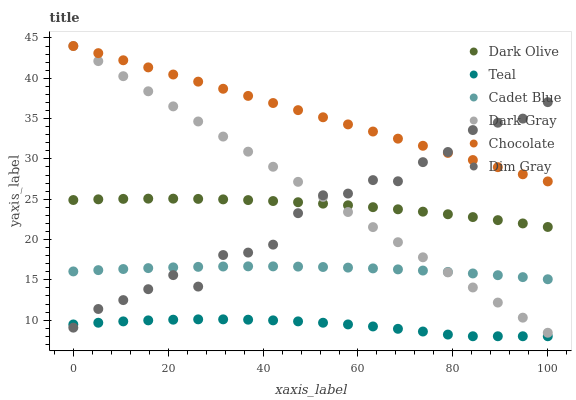Does Teal have the minimum area under the curve?
Answer yes or no. Yes. Does Chocolate have the maximum area under the curve?
Answer yes or no. Yes. Does Dark Olive have the minimum area under the curve?
Answer yes or no. No. Does Dark Olive have the maximum area under the curve?
Answer yes or no. No. Is Dark Gray the smoothest?
Answer yes or no. Yes. Is Dim Gray the roughest?
Answer yes or no. Yes. Is Dark Olive the smoothest?
Answer yes or no. No. Is Dark Olive the roughest?
Answer yes or no. No. Does Teal have the lowest value?
Answer yes or no. Yes. Does Dark Olive have the lowest value?
Answer yes or no. No. Does Dark Gray have the highest value?
Answer yes or no. Yes. Does Dark Olive have the highest value?
Answer yes or no. No. Is Teal less than Dark Gray?
Answer yes or no. Yes. Is Chocolate greater than Cadet Blue?
Answer yes or no. Yes. Does Dim Gray intersect Cadet Blue?
Answer yes or no. Yes. Is Dim Gray less than Cadet Blue?
Answer yes or no. No. Is Dim Gray greater than Cadet Blue?
Answer yes or no. No. Does Teal intersect Dark Gray?
Answer yes or no. No. 